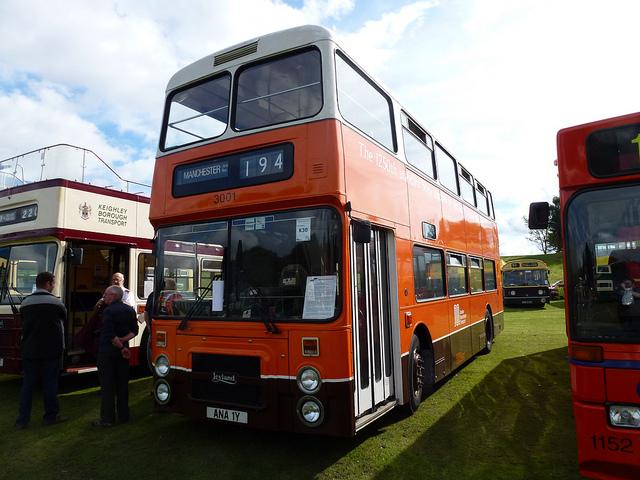What number is on the bus in the middle?

Choices:
A) 888
B) 202
C) 194
D) 456 194 